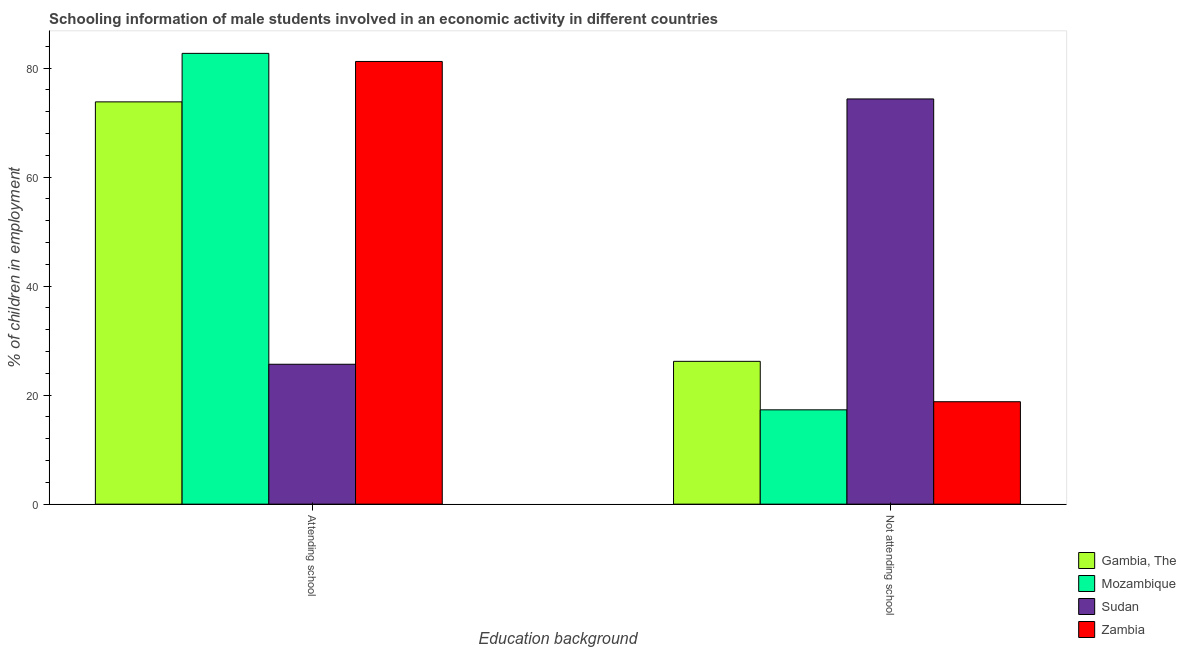Are the number of bars per tick equal to the number of legend labels?
Give a very brief answer. Yes. How many bars are there on the 2nd tick from the left?
Ensure brevity in your answer.  4. What is the label of the 1st group of bars from the left?
Keep it short and to the point. Attending school. What is the percentage of employed males who are not attending school in Sudan?
Provide a succinct answer. 74.33. Across all countries, what is the maximum percentage of employed males who are not attending school?
Keep it short and to the point. 74.33. Across all countries, what is the minimum percentage of employed males who are attending school?
Make the answer very short. 25.67. In which country was the percentage of employed males who are not attending school maximum?
Your response must be concise. Sudan. In which country was the percentage of employed males who are not attending school minimum?
Keep it short and to the point. Mozambique. What is the total percentage of employed males who are not attending school in the graph?
Provide a succinct answer. 136.63. What is the difference between the percentage of employed males who are not attending school in Gambia, The and that in Mozambique?
Make the answer very short. 8.9. What is the difference between the percentage of employed males who are not attending school in Mozambique and the percentage of employed males who are attending school in Sudan?
Provide a short and direct response. -8.36. What is the average percentage of employed males who are not attending school per country?
Provide a short and direct response. 34.16. What is the difference between the percentage of employed males who are attending school and percentage of employed males who are not attending school in Zambia?
Provide a succinct answer. 62.42. In how many countries, is the percentage of employed males who are attending school greater than 60 %?
Make the answer very short. 3. What is the ratio of the percentage of employed males who are attending school in Mozambique to that in Sudan?
Ensure brevity in your answer.  3.22. Is the percentage of employed males who are not attending school in Mozambique less than that in Gambia, The?
Your answer should be very brief. Yes. In how many countries, is the percentage of employed males who are not attending school greater than the average percentage of employed males who are not attending school taken over all countries?
Offer a very short reply. 1. What does the 2nd bar from the left in Not attending school represents?
Keep it short and to the point. Mozambique. What does the 1st bar from the right in Not attending school represents?
Give a very brief answer. Zambia. How many countries are there in the graph?
Provide a succinct answer. 4. What is the difference between two consecutive major ticks on the Y-axis?
Provide a succinct answer. 20. Does the graph contain any zero values?
Offer a terse response. No. Does the graph contain grids?
Your response must be concise. No. How many legend labels are there?
Make the answer very short. 4. How are the legend labels stacked?
Your answer should be very brief. Vertical. What is the title of the graph?
Ensure brevity in your answer.  Schooling information of male students involved in an economic activity in different countries. Does "Malaysia" appear as one of the legend labels in the graph?
Your answer should be very brief. No. What is the label or title of the X-axis?
Your response must be concise. Education background. What is the label or title of the Y-axis?
Ensure brevity in your answer.  % of children in employment. What is the % of children in employment in Gambia, The in Attending school?
Keep it short and to the point. 73.8. What is the % of children in employment in Mozambique in Attending school?
Make the answer very short. 82.7. What is the % of children in employment in Sudan in Attending school?
Offer a very short reply. 25.67. What is the % of children in employment of Zambia in Attending school?
Offer a very short reply. 81.21. What is the % of children in employment in Gambia, The in Not attending school?
Your answer should be compact. 26.2. What is the % of children in employment of Mozambique in Not attending school?
Offer a very short reply. 17.3. What is the % of children in employment in Sudan in Not attending school?
Your answer should be compact. 74.33. What is the % of children in employment in Zambia in Not attending school?
Provide a succinct answer. 18.79. Across all Education background, what is the maximum % of children in employment in Gambia, The?
Your response must be concise. 73.8. Across all Education background, what is the maximum % of children in employment in Mozambique?
Provide a succinct answer. 82.7. Across all Education background, what is the maximum % of children in employment in Sudan?
Keep it short and to the point. 74.33. Across all Education background, what is the maximum % of children in employment in Zambia?
Your answer should be very brief. 81.21. Across all Education background, what is the minimum % of children in employment of Gambia, The?
Offer a terse response. 26.2. Across all Education background, what is the minimum % of children in employment in Mozambique?
Give a very brief answer. 17.3. Across all Education background, what is the minimum % of children in employment of Sudan?
Your answer should be very brief. 25.67. Across all Education background, what is the minimum % of children in employment of Zambia?
Keep it short and to the point. 18.79. What is the total % of children in employment in Gambia, The in the graph?
Offer a very short reply. 100. What is the total % of children in employment of Mozambique in the graph?
Keep it short and to the point. 100. What is the total % of children in employment of Zambia in the graph?
Offer a very short reply. 100. What is the difference between the % of children in employment of Gambia, The in Attending school and that in Not attending school?
Your answer should be compact. 47.6. What is the difference between the % of children in employment of Mozambique in Attending school and that in Not attending school?
Provide a succinct answer. 65.39. What is the difference between the % of children in employment of Sudan in Attending school and that in Not attending school?
Your answer should be compact. -48.67. What is the difference between the % of children in employment in Zambia in Attending school and that in Not attending school?
Keep it short and to the point. 62.42. What is the difference between the % of children in employment of Gambia, The in Attending school and the % of children in employment of Mozambique in Not attending school?
Give a very brief answer. 56.5. What is the difference between the % of children in employment in Gambia, The in Attending school and the % of children in employment in Sudan in Not attending school?
Keep it short and to the point. -0.53. What is the difference between the % of children in employment of Gambia, The in Attending school and the % of children in employment of Zambia in Not attending school?
Ensure brevity in your answer.  55.01. What is the difference between the % of children in employment of Mozambique in Attending school and the % of children in employment of Sudan in Not attending school?
Give a very brief answer. 8.36. What is the difference between the % of children in employment of Mozambique in Attending school and the % of children in employment of Zambia in Not attending school?
Ensure brevity in your answer.  63.91. What is the difference between the % of children in employment of Sudan in Attending school and the % of children in employment of Zambia in Not attending school?
Offer a terse response. 6.88. What is the average % of children in employment in Gambia, The per Education background?
Your answer should be compact. 50. What is the average % of children in employment in Sudan per Education background?
Give a very brief answer. 50. What is the difference between the % of children in employment of Gambia, The and % of children in employment of Mozambique in Attending school?
Your answer should be compact. -8.9. What is the difference between the % of children in employment in Gambia, The and % of children in employment in Sudan in Attending school?
Your answer should be compact. 48.13. What is the difference between the % of children in employment in Gambia, The and % of children in employment in Zambia in Attending school?
Offer a very short reply. -7.41. What is the difference between the % of children in employment of Mozambique and % of children in employment of Sudan in Attending school?
Offer a very short reply. 57.03. What is the difference between the % of children in employment of Mozambique and % of children in employment of Zambia in Attending school?
Make the answer very short. 1.49. What is the difference between the % of children in employment in Sudan and % of children in employment in Zambia in Attending school?
Offer a very short reply. -55.55. What is the difference between the % of children in employment in Gambia, The and % of children in employment in Mozambique in Not attending school?
Your response must be concise. 8.9. What is the difference between the % of children in employment in Gambia, The and % of children in employment in Sudan in Not attending school?
Provide a short and direct response. -48.13. What is the difference between the % of children in employment in Gambia, The and % of children in employment in Zambia in Not attending school?
Give a very brief answer. 7.41. What is the difference between the % of children in employment of Mozambique and % of children in employment of Sudan in Not attending school?
Provide a succinct answer. -57.03. What is the difference between the % of children in employment of Mozambique and % of children in employment of Zambia in Not attending school?
Make the answer very short. -1.49. What is the difference between the % of children in employment of Sudan and % of children in employment of Zambia in Not attending school?
Give a very brief answer. 55.55. What is the ratio of the % of children in employment of Gambia, The in Attending school to that in Not attending school?
Give a very brief answer. 2.82. What is the ratio of the % of children in employment in Mozambique in Attending school to that in Not attending school?
Keep it short and to the point. 4.78. What is the ratio of the % of children in employment of Sudan in Attending school to that in Not attending school?
Provide a short and direct response. 0.35. What is the ratio of the % of children in employment of Zambia in Attending school to that in Not attending school?
Your answer should be compact. 4.32. What is the difference between the highest and the second highest % of children in employment of Gambia, The?
Offer a terse response. 47.6. What is the difference between the highest and the second highest % of children in employment in Mozambique?
Your answer should be compact. 65.39. What is the difference between the highest and the second highest % of children in employment in Sudan?
Provide a succinct answer. 48.67. What is the difference between the highest and the second highest % of children in employment of Zambia?
Provide a succinct answer. 62.42. What is the difference between the highest and the lowest % of children in employment of Gambia, The?
Keep it short and to the point. 47.6. What is the difference between the highest and the lowest % of children in employment in Mozambique?
Your answer should be compact. 65.39. What is the difference between the highest and the lowest % of children in employment of Sudan?
Offer a very short reply. 48.67. What is the difference between the highest and the lowest % of children in employment in Zambia?
Give a very brief answer. 62.42. 